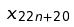<formula> <loc_0><loc_0><loc_500><loc_500>x _ { 2 2 n + 2 0 }</formula> 